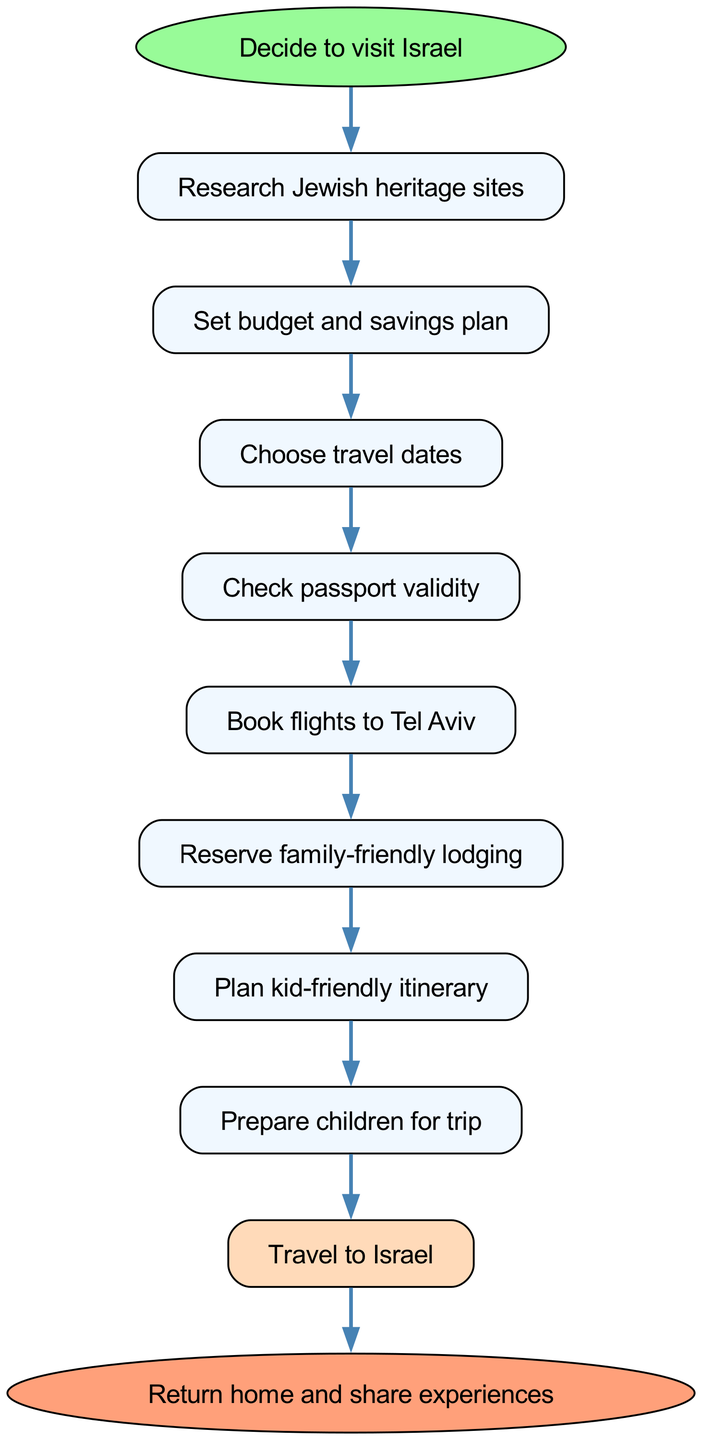What is the starting point in the diagram? The diagram begins at the "Decide to visit Israel" node, which is the first step in the planned lifecycle of the family trip.
Answer: Decide to visit Israel How many nodes are there in the diagram? By counting all the distinct steps from the start to the end, including preparation and travel actions, the total number of nodes is 11.
Answer: 11 What is the last step before returning home? The final action before returning home is "Travel to Israel", which occurs just before the end of the process where the family shares their experiences.
Answer: Travel to Israel Which step follows "Plan kid-friendly itinerary"? After planning the itinerary for the kids, the next step is "Prepare children for trip", indicating the importance of getting the children ready for the travel.
Answer: Prepare children for trip What is the relationship between "Set budget and savings plan" and "Choose travel dates"? "Set budget and savings plan" is a prerequisite to "Choose travel dates", meaning the family must establish a budget before determining when to travel.
Answer: Sequential relationship (budget → dates) What type of node is the starting point represented as? In the diagram, the starting point "Decide to visit Israel" is represented as an ellipse, differentiating it from other nodes that are rectangles.
Answer: Ellipse What is the key action after checking passport validity? The crucial next step following "Check passport validity" is to "Book flights to Tel Aviv", indicating that once passports are confirmed, flight arrangements can proceed.
Answer: Book flights to Tel Aviv How does the journey to the trip initiate? The journey to planning the trip begins with the decision to visit Israel, setting off the entire sequence of actions that must be taken.
Answer: Decide to visit Israel What is the color of the node representing the end of the process? The final node, which signifies the end of the process, "Return home and share experiences", is filled with a light salmon color indicated in the diagram's attributes.
Answer: Light salmon color How many edges connect the main flow from start to end? The main flow of the process has 10 edges connecting each crucial step until reaching the conclusion of the trip.
Answer: 10 